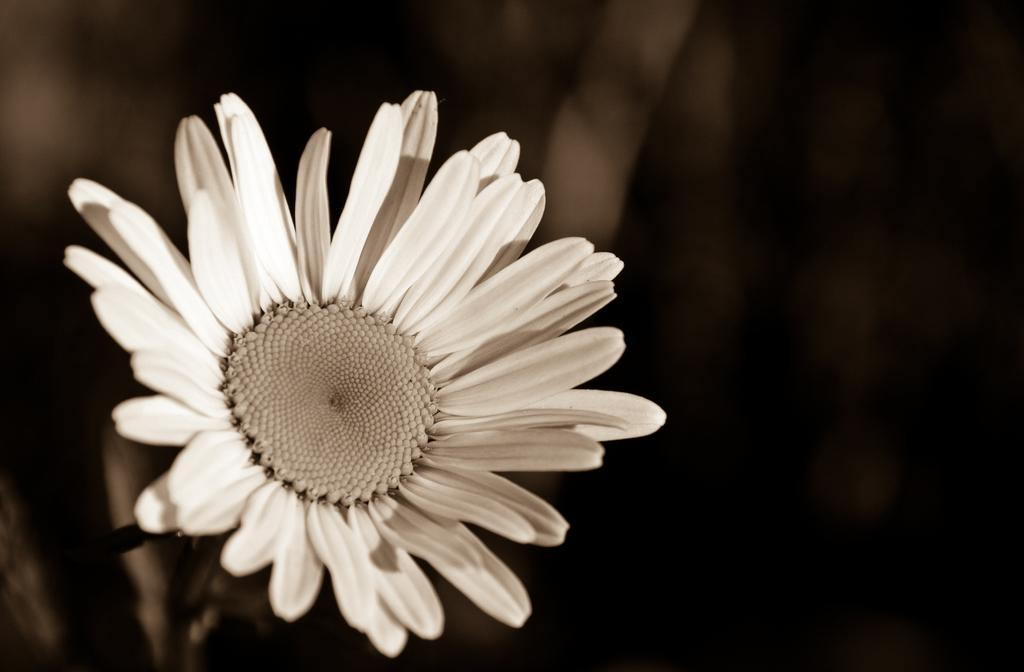What type of flower is in the image? There is a white flower in the image. Can you describe the background of the image? The background of the image is blurred. Is there an earthquake happening in the image? There is no indication of an earthquake in the image; it features a white flower with a blurred background. 